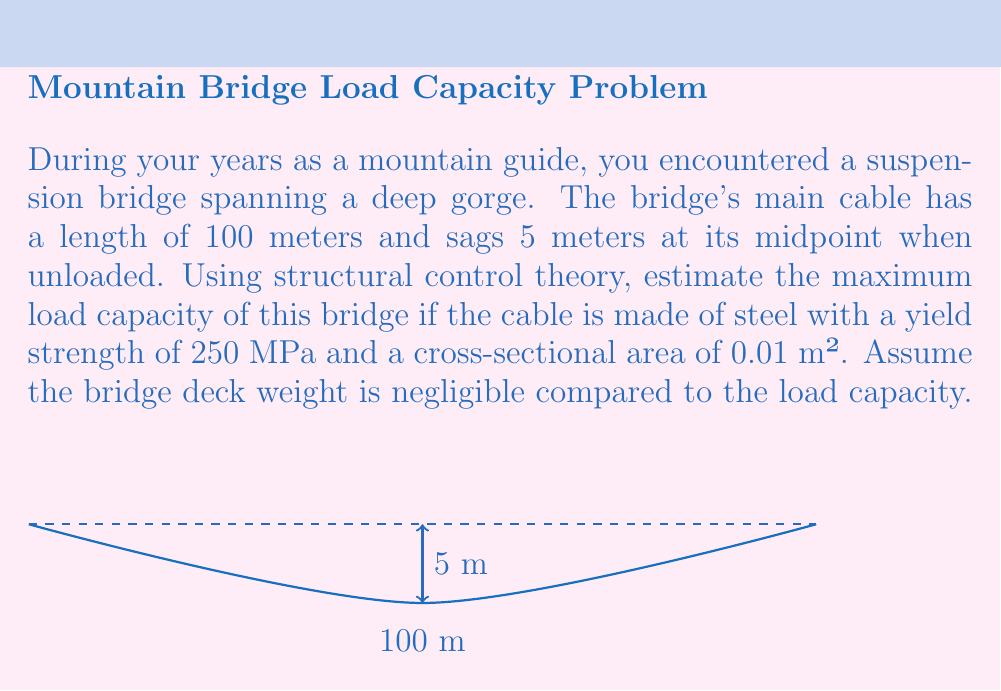Show me your answer to this math problem. To estimate the maximum load capacity using structural control theory, we'll follow these steps:

1) First, we need to determine the tension in the cable. For a shallow catenary (where the sag is small compared to the span), we can use the parabolic approximation:

   $$T = \frac{wL^2}{8d}$$

   where $T$ is the tension, $w$ is the distributed load, $L$ is the span, and $d$ is the sag.

2) We don't know $w$ yet, but we know that the maximum tension should not exceed the yield strength of the cable. The maximum stress $\sigma$ in the cable is:

   $$\sigma = \frac{T}{A}$$

   where $A$ is the cross-sectional area of the cable.

3) Setting this equal to the yield strength and solving for $T$:

   $$T_{max} = \sigma_{yield} \cdot A = 250 \times 10^6 \cdot 0.01 = 2.5 \times 10^6 \text{ N}$$

4) Now we can solve for the maximum distributed load $w_{max}$:

   $$w_{max} = \frac{8dT_{max}}{L^2} = \frac{8 \cdot 5 \cdot (2.5 \times 10^6)}{100^2} = 10,000 \text{ N/m}$$

5) To get the total load capacity, we multiply by the span:

   $$P_{max} = w_{max} \cdot L = 10,000 \cdot 100 = 1,000,000 \text{ N} = 1 \text{ MN}$$

6) Converting to metric tons:

   $$1 \text{ MN} \approx 102 \text{ metric tons}$$

Therefore, the estimated maximum load capacity of the bridge is approximately 102 metric tons.
Answer: 102 metric tons 